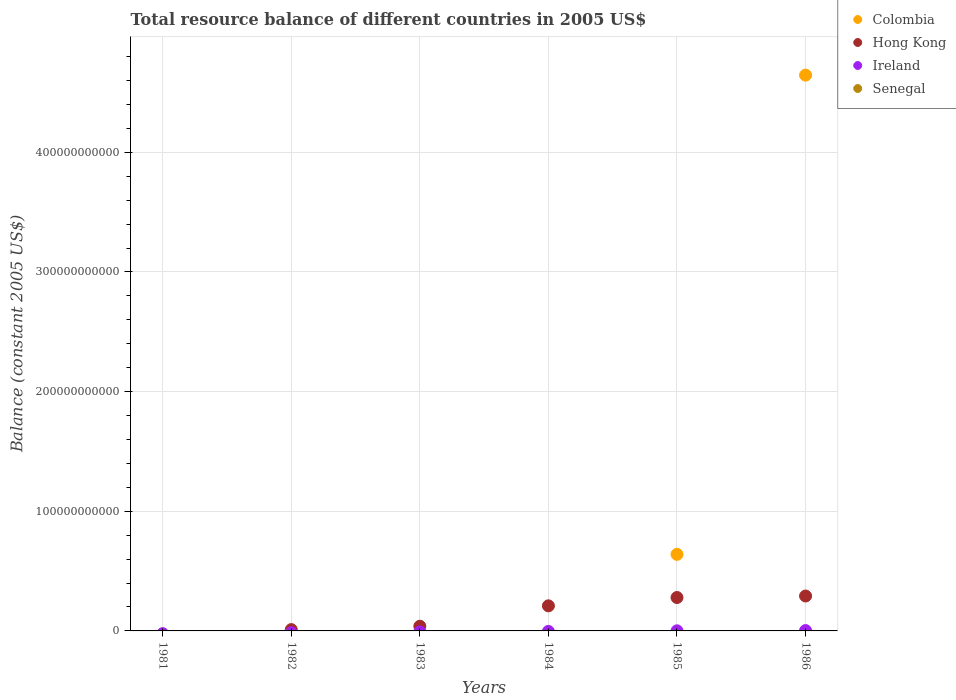How many different coloured dotlines are there?
Offer a terse response. 3. Across all years, what is the maximum total resource balance in Ireland?
Make the answer very short. 2.91e+08. What is the total total resource balance in Hong Kong in the graph?
Give a very brief answer. 8.31e+1. What is the difference between the total resource balance in Hong Kong in 1984 and that in 1985?
Provide a succinct answer. -6.96e+09. What is the difference between the total resource balance in Colombia in 1986 and the total resource balance in Hong Kong in 1982?
Offer a terse response. 4.63e+11. What is the average total resource balance in Senegal per year?
Ensure brevity in your answer.  0. In the year 1986, what is the difference between the total resource balance in Ireland and total resource balance in Hong Kong?
Make the answer very short. -2.89e+1. In how many years, is the total resource balance in Hong Kong greater than 400000000000 US$?
Your answer should be very brief. 0. What is the ratio of the total resource balance in Ireland in 1985 to that in 1986?
Keep it short and to the point. 0.28. Is the total resource balance in Hong Kong in 1982 less than that in 1983?
Make the answer very short. Yes. What is the difference between the highest and the second highest total resource balance in Hong Kong?
Keep it short and to the point. 1.26e+09. What is the difference between the highest and the lowest total resource balance in Ireland?
Keep it short and to the point. 2.91e+08. Is it the case that in every year, the sum of the total resource balance in Colombia and total resource balance in Hong Kong  is greater than the sum of total resource balance in Senegal and total resource balance in Ireland?
Offer a terse response. No. Is it the case that in every year, the sum of the total resource balance in Colombia and total resource balance in Ireland  is greater than the total resource balance in Senegal?
Your answer should be very brief. No. Does the total resource balance in Colombia monotonically increase over the years?
Make the answer very short. No. How many dotlines are there?
Your answer should be very brief. 3. How many years are there in the graph?
Provide a succinct answer. 6. What is the difference between two consecutive major ticks on the Y-axis?
Offer a terse response. 1.00e+11. Does the graph contain any zero values?
Give a very brief answer. Yes. Does the graph contain grids?
Your response must be concise. Yes. Where does the legend appear in the graph?
Provide a succinct answer. Top right. How many legend labels are there?
Provide a short and direct response. 4. What is the title of the graph?
Offer a very short reply. Total resource balance of different countries in 2005 US$. What is the label or title of the X-axis?
Provide a short and direct response. Years. What is the label or title of the Y-axis?
Your answer should be very brief. Balance (constant 2005 US$). What is the Balance (constant 2005 US$) of Colombia in 1981?
Your response must be concise. 0. What is the Balance (constant 2005 US$) of Ireland in 1981?
Provide a succinct answer. 0. What is the Balance (constant 2005 US$) of Hong Kong in 1982?
Ensure brevity in your answer.  1.11e+09. What is the Balance (constant 2005 US$) in Ireland in 1982?
Give a very brief answer. 0. What is the Balance (constant 2005 US$) of Senegal in 1982?
Offer a terse response. 0. What is the Balance (constant 2005 US$) of Hong Kong in 1983?
Give a very brief answer. 3.92e+09. What is the Balance (constant 2005 US$) in Ireland in 1983?
Provide a short and direct response. 0. What is the Balance (constant 2005 US$) of Hong Kong in 1984?
Your response must be concise. 2.10e+1. What is the Balance (constant 2005 US$) in Senegal in 1984?
Provide a succinct answer. 0. What is the Balance (constant 2005 US$) in Colombia in 1985?
Offer a very short reply. 6.40e+1. What is the Balance (constant 2005 US$) of Hong Kong in 1985?
Your answer should be very brief. 2.79e+1. What is the Balance (constant 2005 US$) of Ireland in 1985?
Provide a succinct answer. 8.03e+07. What is the Balance (constant 2005 US$) in Senegal in 1985?
Give a very brief answer. 0. What is the Balance (constant 2005 US$) in Colombia in 1986?
Your response must be concise. 4.65e+11. What is the Balance (constant 2005 US$) of Hong Kong in 1986?
Give a very brief answer. 2.92e+1. What is the Balance (constant 2005 US$) in Ireland in 1986?
Your answer should be compact. 2.91e+08. Across all years, what is the maximum Balance (constant 2005 US$) in Colombia?
Make the answer very short. 4.65e+11. Across all years, what is the maximum Balance (constant 2005 US$) in Hong Kong?
Offer a terse response. 2.92e+1. Across all years, what is the maximum Balance (constant 2005 US$) in Ireland?
Provide a succinct answer. 2.91e+08. Across all years, what is the minimum Balance (constant 2005 US$) in Colombia?
Ensure brevity in your answer.  0. What is the total Balance (constant 2005 US$) in Colombia in the graph?
Offer a very short reply. 5.29e+11. What is the total Balance (constant 2005 US$) in Hong Kong in the graph?
Keep it short and to the point. 8.31e+1. What is the total Balance (constant 2005 US$) in Ireland in the graph?
Make the answer very short. 3.71e+08. What is the total Balance (constant 2005 US$) of Senegal in the graph?
Your answer should be compact. 0. What is the difference between the Balance (constant 2005 US$) of Hong Kong in 1982 and that in 1983?
Your answer should be very brief. -2.82e+09. What is the difference between the Balance (constant 2005 US$) in Hong Kong in 1982 and that in 1984?
Ensure brevity in your answer.  -1.99e+1. What is the difference between the Balance (constant 2005 US$) of Hong Kong in 1982 and that in 1985?
Ensure brevity in your answer.  -2.68e+1. What is the difference between the Balance (constant 2005 US$) in Hong Kong in 1982 and that in 1986?
Your response must be concise. -2.81e+1. What is the difference between the Balance (constant 2005 US$) of Hong Kong in 1983 and that in 1984?
Make the answer very short. -1.70e+1. What is the difference between the Balance (constant 2005 US$) of Hong Kong in 1983 and that in 1985?
Provide a succinct answer. -2.40e+1. What is the difference between the Balance (constant 2005 US$) in Hong Kong in 1983 and that in 1986?
Your answer should be compact. -2.53e+1. What is the difference between the Balance (constant 2005 US$) of Hong Kong in 1984 and that in 1985?
Give a very brief answer. -6.96e+09. What is the difference between the Balance (constant 2005 US$) of Hong Kong in 1984 and that in 1986?
Your answer should be very brief. -8.21e+09. What is the difference between the Balance (constant 2005 US$) in Colombia in 1985 and that in 1986?
Keep it short and to the point. -4.01e+11. What is the difference between the Balance (constant 2005 US$) of Hong Kong in 1985 and that in 1986?
Keep it short and to the point. -1.26e+09. What is the difference between the Balance (constant 2005 US$) in Ireland in 1985 and that in 1986?
Keep it short and to the point. -2.10e+08. What is the difference between the Balance (constant 2005 US$) in Hong Kong in 1982 and the Balance (constant 2005 US$) in Ireland in 1985?
Your answer should be very brief. 1.03e+09. What is the difference between the Balance (constant 2005 US$) in Hong Kong in 1982 and the Balance (constant 2005 US$) in Ireland in 1986?
Your answer should be compact. 8.15e+08. What is the difference between the Balance (constant 2005 US$) in Hong Kong in 1983 and the Balance (constant 2005 US$) in Ireland in 1985?
Offer a very short reply. 3.84e+09. What is the difference between the Balance (constant 2005 US$) in Hong Kong in 1983 and the Balance (constant 2005 US$) in Ireland in 1986?
Your answer should be very brief. 3.63e+09. What is the difference between the Balance (constant 2005 US$) of Hong Kong in 1984 and the Balance (constant 2005 US$) of Ireland in 1985?
Your answer should be very brief. 2.09e+1. What is the difference between the Balance (constant 2005 US$) in Hong Kong in 1984 and the Balance (constant 2005 US$) in Ireland in 1986?
Your response must be concise. 2.07e+1. What is the difference between the Balance (constant 2005 US$) of Colombia in 1985 and the Balance (constant 2005 US$) of Hong Kong in 1986?
Make the answer very short. 3.48e+1. What is the difference between the Balance (constant 2005 US$) of Colombia in 1985 and the Balance (constant 2005 US$) of Ireland in 1986?
Provide a short and direct response. 6.37e+1. What is the difference between the Balance (constant 2005 US$) in Hong Kong in 1985 and the Balance (constant 2005 US$) in Ireland in 1986?
Offer a very short reply. 2.76e+1. What is the average Balance (constant 2005 US$) in Colombia per year?
Make the answer very short. 8.81e+1. What is the average Balance (constant 2005 US$) of Hong Kong per year?
Offer a very short reply. 1.38e+1. What is the average Balance (constant 2005 US$) in Ireland per year?
Provide a short and direct response. 6.18e+07. In the year 1985, what is the difference between the Balance (constant 2005 US$) of Colombia and Balance (constant 2005 US$) of Hong Kong?
Ensure brevity in your answer.  3.61e+1. In the year 1985, what is the difference between the Balance (constant 2005 US$) of Colombia and Balance (constant 2005 US$) of Ireland?
Your answer should be compact. 6.39e+1. In the year 1985, what is the difference between the Balance (constant 2005 US$) in Hong Kong and Balance (constant 2005 US$) in Ireland?
Make the answer very short. 2.78e+1. In the year 1986, what is the difference between the Balance (constant 2005 US$) of Colombia and Balance (constant 2005 US$) of Hong Kong?
Give a very brief answer. 4.35e+11. In the year 1986, what is the difference between the Balance (constant 2005 US$) in Colombia and Balance (constant 2005 US$) in Ireland?
Offer a terse response. 4.64e+11. In the year 1986, what is the difference between the Balance (constant 2005 US$) in Hong Kong and Balance (constant 2005 US$) in Ireland?
Provide a short and direct response. 2.89e+1. What is the ratio of the Balance (constant 2005 US$) of Hong Kong in 1982 to that in 1983?
Keep it short and to the point. 0.28. What is the ratio of the Balance (constant 2005 US$) of Hong Kong in 1982 to that in 1984?
Provide a succinct answer. 0.05. What is the ratio of the Balance (constant 2005 US$) in Hong Kong in 1982 to that in 1985?
Your response must be concise. 0.04. What is the ratio of the Balance (constant 2005 US$) of Hong Kong in 1982 to that in 1986?
Give a very brief answer. 0.04. What is the ratio of the Balance (constant 2005 US$) in Hong Kong in 1983 to that in 1984?
Provide a short and direct response. 0.19. What is the ratio of the Balance (constant 2005 US$) of Hong Kong in 1983 to that in 1985?
Ensure brevity in your answer.  0.14. What is the ratio of the Balance (constant 2005 US$) of Hong Kong in 1983 to that in 1986?
Ensure brevity in your answer.  0.13. What is the ratio of the Balance (constant 2005 US$) in Hong Kong in 1984 to that in 1985?
Your answer should be compact. 0.75. What is the ratio of the Balance (constant 2005 US$) of Hong Kong in 1984 to that in 1986?
Offer a very short reply. 0.72. What is the ratio of the Balance (constant 2005 US$) in Colombia in 1985 to that in 1986?
Provide a succinct answer. 0.14. What is the ratio of the Balance (constant 2005 US$) of Hong Kong in 1985 to that in 1986?
Give a very brief answer. 0.96. What is the ratio of the Balance (constant 2005 US$) in Ireland in 1985 to that in 1986?
Provide a succinct answer. 0.28. What is the difference between the highest and the second highest Balance (constant 2005 US$) of Hong Kong?
Your answer should be very brief. 1.26e+09. What is the difference between the highest and the lowest Balance (constant 2005 US$) of Colombia?
Offer a very short reply. 4.65e+11. What is the difference between the highest and the lowest Balance (constant 2005 US$) of Hong Kong?
Offer a terse response. 2.92e+1. What is the difference between the highest and the lowest Balance (constant 2005 US$) in Ireland?
Your answer should be compact. 2.91e+08. 